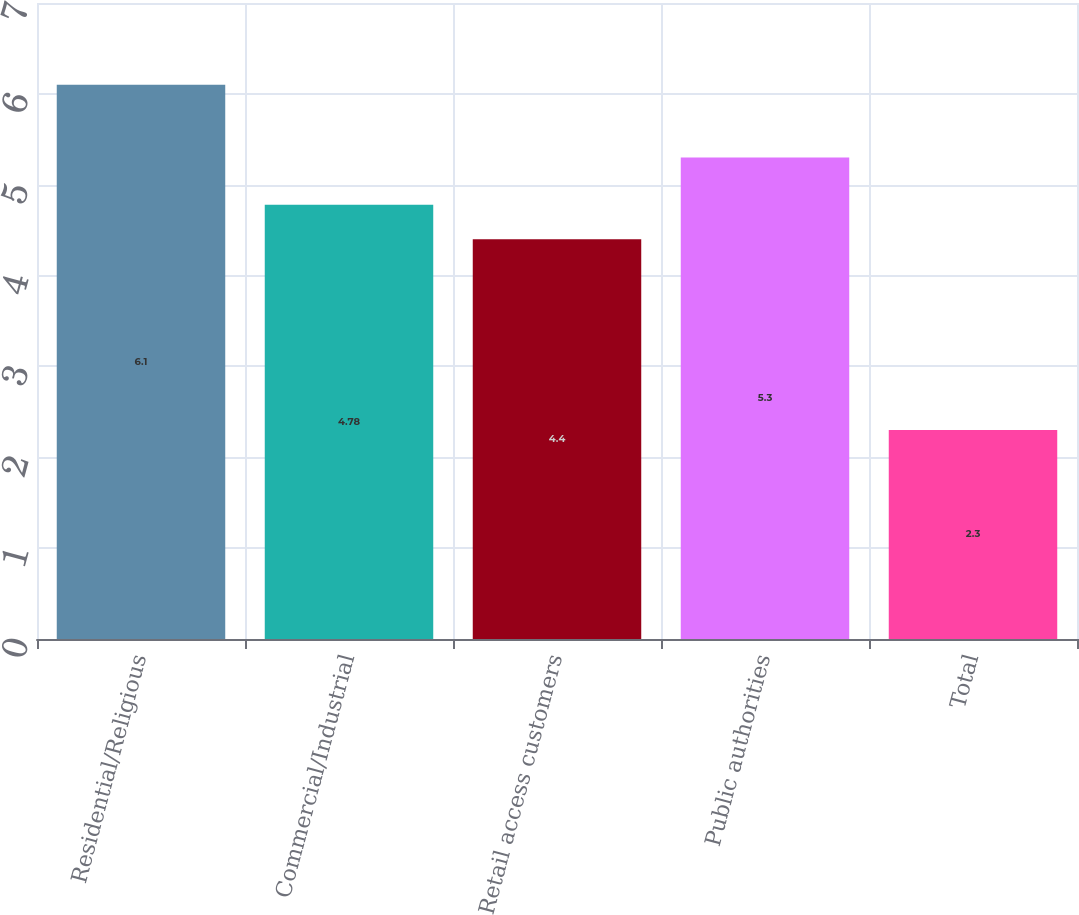Convert chart. <chart><loc_0><loc_0><loc_500><loc_500><bar_chart><fcel>Residential/Religious<fcel>Commercial/Industrial<fcel>Retail access customers<fcel>Public authorities<fcel>Total<nl><fcel>6.1<fcel>4.78<fcel>4.4<fcel>5.3<fcel>2.3<nl></chart> 